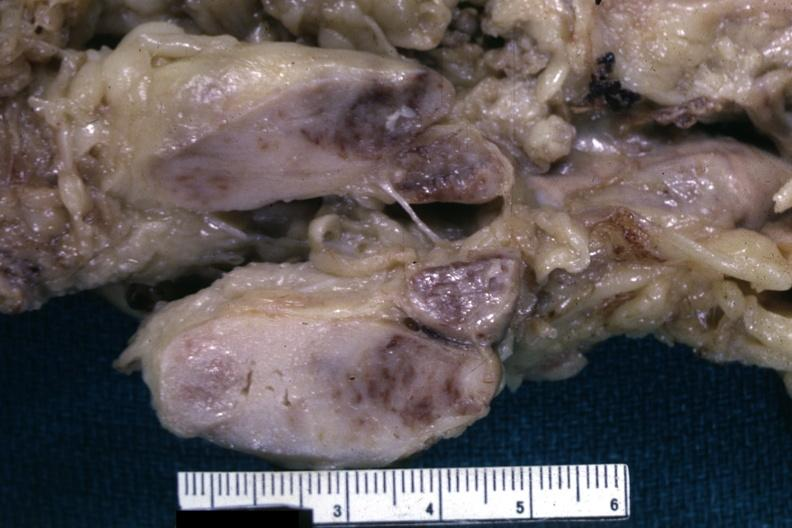how is matting history of this case unknown could have been a seminoma see slides?
Answer the question using a single word or phrase. Other 